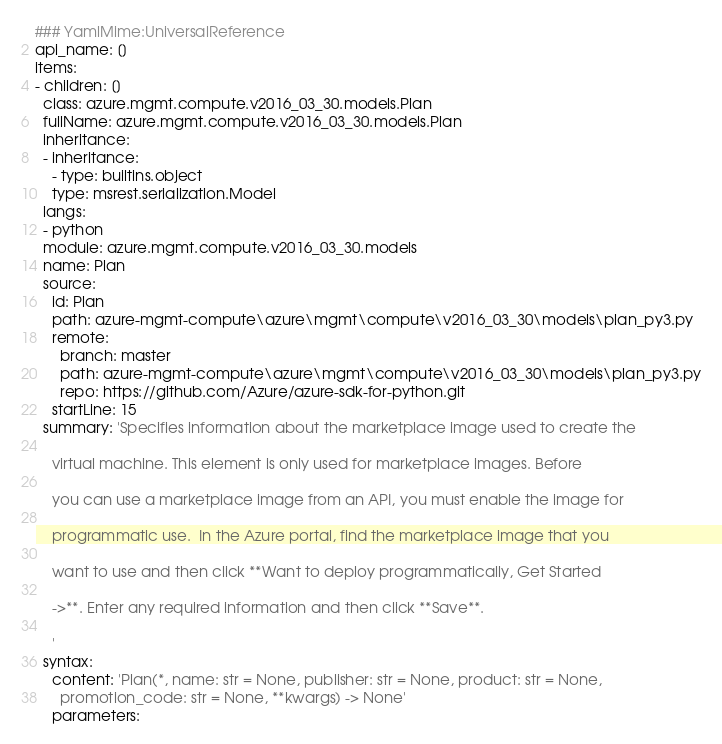<code> <loc_0><loc_0><loc_500><loc_500><_YAML_>### YamlMime:UniversalReference
api_name: []
items:
- children: []
  class: azure.mgmt.compute.v2016_03_30.models.Plan
  fullName: azure.mgmt.compute.v2016_03_30.models.Plan
  inheritance:
  - inheritance:
    - type: builtins.object
    type: msrest.serialization.Model
  langs:
  - python
  module: azure.mgmt.compute.v2016_03_30.models
  name: Plan
  source:
    id: Plan
    path: azure-mgmt-compute\azure\mgmt\compute\v2016_03_30\models\plan_py3.py
    remote:
      branch: master
      path: azure-mgmt-compute\azure\mgmt\compute\v2016_03_30\models\plan_py3.py
      repo: https://github.com/Azure/azure-sdk-for-python.git
    startLine: 15
  summary: 'Specifies information about the marketplace image used to create the

    virtual machine. This element is only used for marketplace images. Before

    you can use a marketplace image from an API, you must enable the image for

    programmatic use.  In the Azure portal, find the marketplace image that you

    want to use and then click **Want to deploy programmatically, Get Started

    ->**. Enter any required information and then click **Save**.

    '
  syntax:
    content: 'Plan(*, name: str = None, publisher: str = None, product: str = None,
      promotion_code: str = None, **kwargs) -> None'
    parameters:</code> 